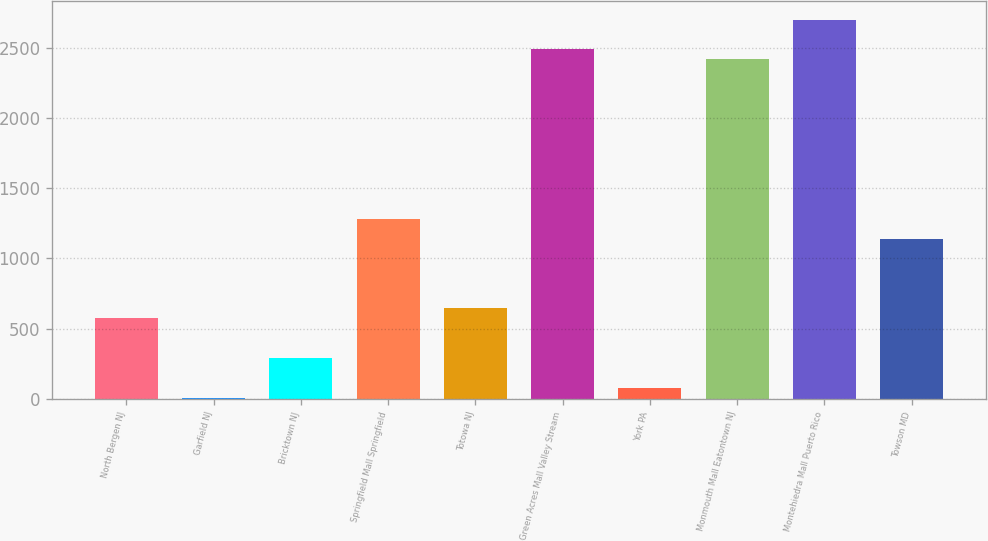Convert chart to OTSL. <chart><loc_0><loc_0><loc_500><loc_500><bar_chart><fcel>North Bergen NJ<fcel>Garfield NJ<fcel>Bricktown NJ<fcel>Springfield Mall Springfield<fcel>Totowa NJ<fcel>Green Acres Mall Valley Stream<fcel>York PA<fcel>Monmouth Mall Eatontown NJ<fcel>Montehiedra Mall Puerto Rico<fcel>Towson MD<nl><fcel>574.13<fcel>7.41<fcel>290.77<fcel>1282.53<fcel>644.97<fcel>2486.81<fcel>78.25<fcel>2415.97<fcel>2699.33<fcel>1140.85<nl></chart> 